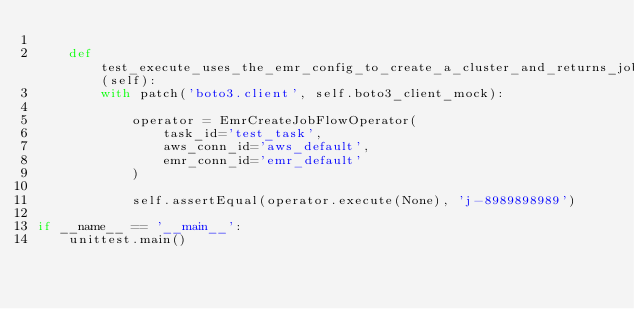<code> <loc_0><loc_0><loc_500><loc_500><_Python_>
    def test_execute_uses_the_emr_config_to_create_a_cluster_and_returns_job_id(self):
        with patch('boto3.client', self.boto3_client_mock):

            operator = EmrCreateJobFlowOperator(
                task_id='test_task',
                aws_conn_id='aws_default',
                emr_conn_id='emr_default'
            )

            self.assertEqual(operator.execute(None), 'j-8989898989')

if __name__ == '__main__':
    unittest.main()
</code> 